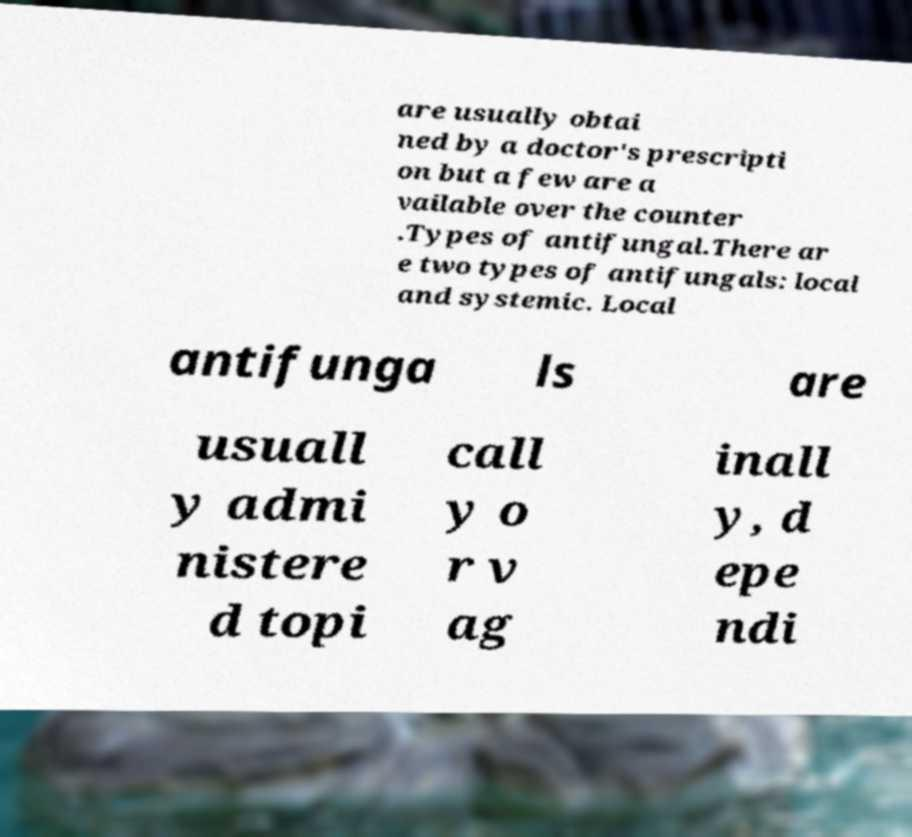Could you extract and type out the text from this image? are usually obtai ned by a doctor's prescripti on but a few are a vailable over the counter .Types of antifungal.There ar e two types of antifungals: local and systemic. Local antifunga ls are usuall y admi nistere d topi call y o r v ag inall y, d epe ndi 